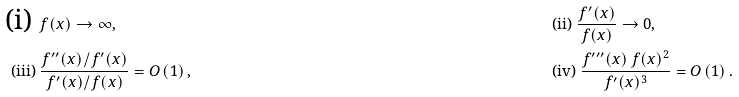<formula> <loc_0><loc_0><loc_500><loc_500>\text {(i) } & f ( x ) \rightarrow \infty , & & \text {(ii) } \frac { f ^ { \prime } ( x ) } { f ( x ) } \rightarrow 0 , \\ \text {(iii) } & \frac { f ^ { \prime \prime } ( x ) / f ^ { \prime } ( x ) } { f ^ { \prime } ( x ) / f ( x ) } = O \left ( 1 \right ) , & & \text {(iv) } \frac { f ^ { \prime \prime \prime } ( x ) \, f ( x ) ^ { 2 } } { f ^ { \prime } ( x ) ^ { 3 } } = O \left ( 1 \right ) .</formula> 